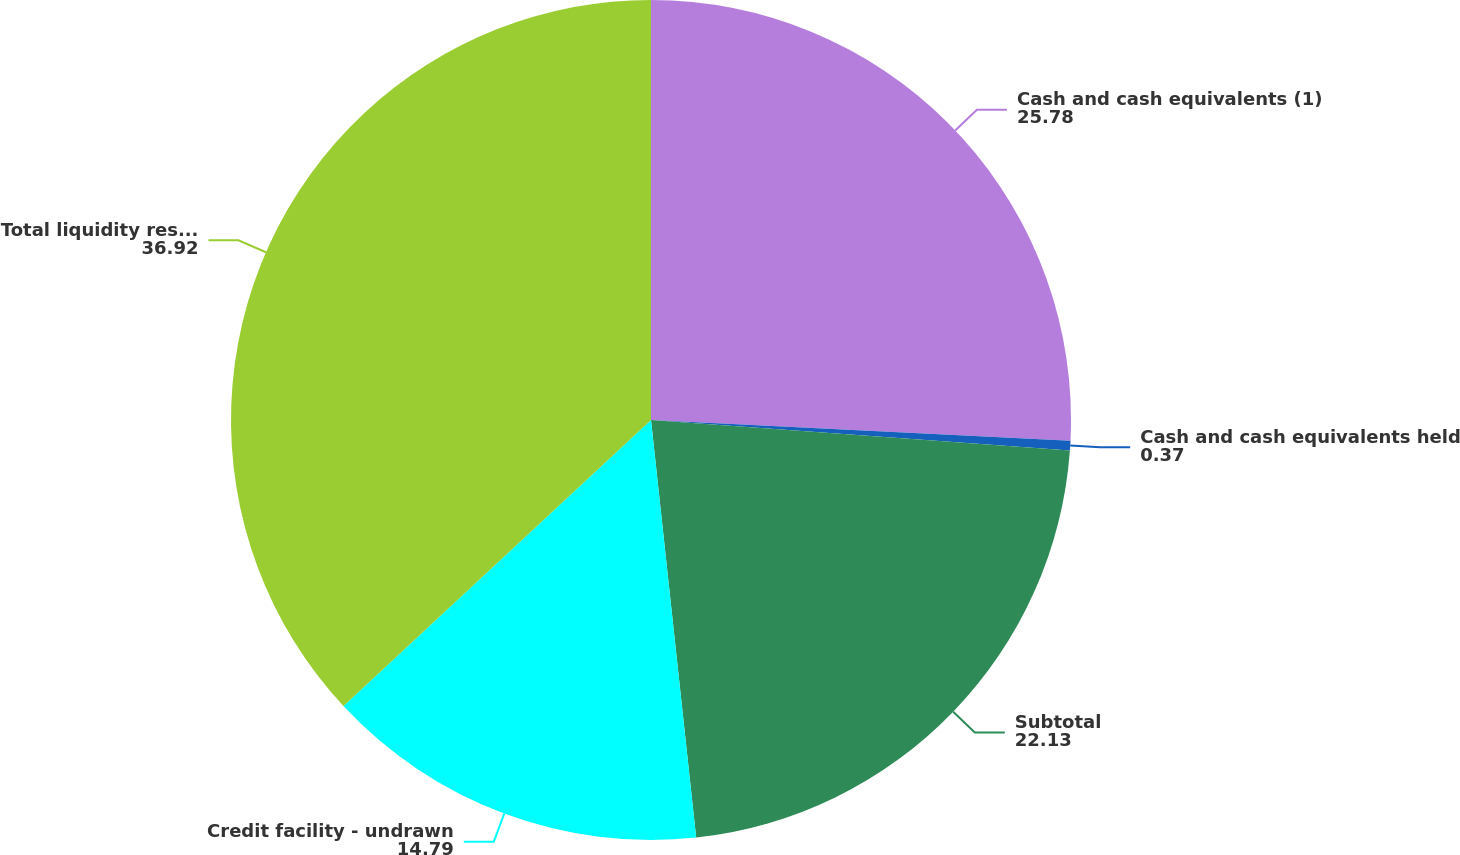Convert chart. <chart><loc_0><loc_0><loc_500><loc_500><pie_chart><fcel>Cash and cash equivalents (1)<fcel>Cash and cash equivalents held<fcel>Subtotal<fcel>Credit facility - undrawn<fcel>Total liquidity resources (3)<nl><fcel>25.78%<fcel>0.37%<fcel>22.13%<fcel>14.79%<fcel>36.92%<nl></chart> 